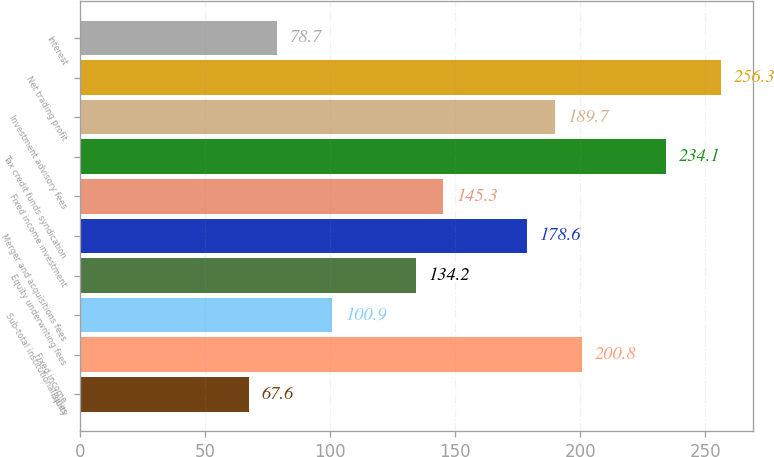<chart> <loc_0><loc_0><loc_500><loc_500><bar_chart><fcel>Equity<fcel>Fixed income<fcel>Sub-total institutional sales<fcel>Equity underwriting fees<fcel>Merger and acquisitions fees<fcel>Fixed income investment<fcel>Tax credit funds syndication<fcel>Investment advisory fees<fcel>Net trading profit<fcel>Interest<nl><fcel>67.6<fcel>200.8<fcel>100.9<fcel>134.2<fcel>178.6<fcel>145.3<fcel>234.1<fcel>189.7<fcel>256.3<fcel>78.7<nl></chart> 